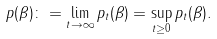<formula> <loc_0><loc_0><loc_500><loc_500>p ( \beta ) \colon = \lim _ { t \rightarrow \infty } p _ { t } ( \beta ) = \sup _ { t \geq 0 } p _ { t } ( \beta ) .</formula> 